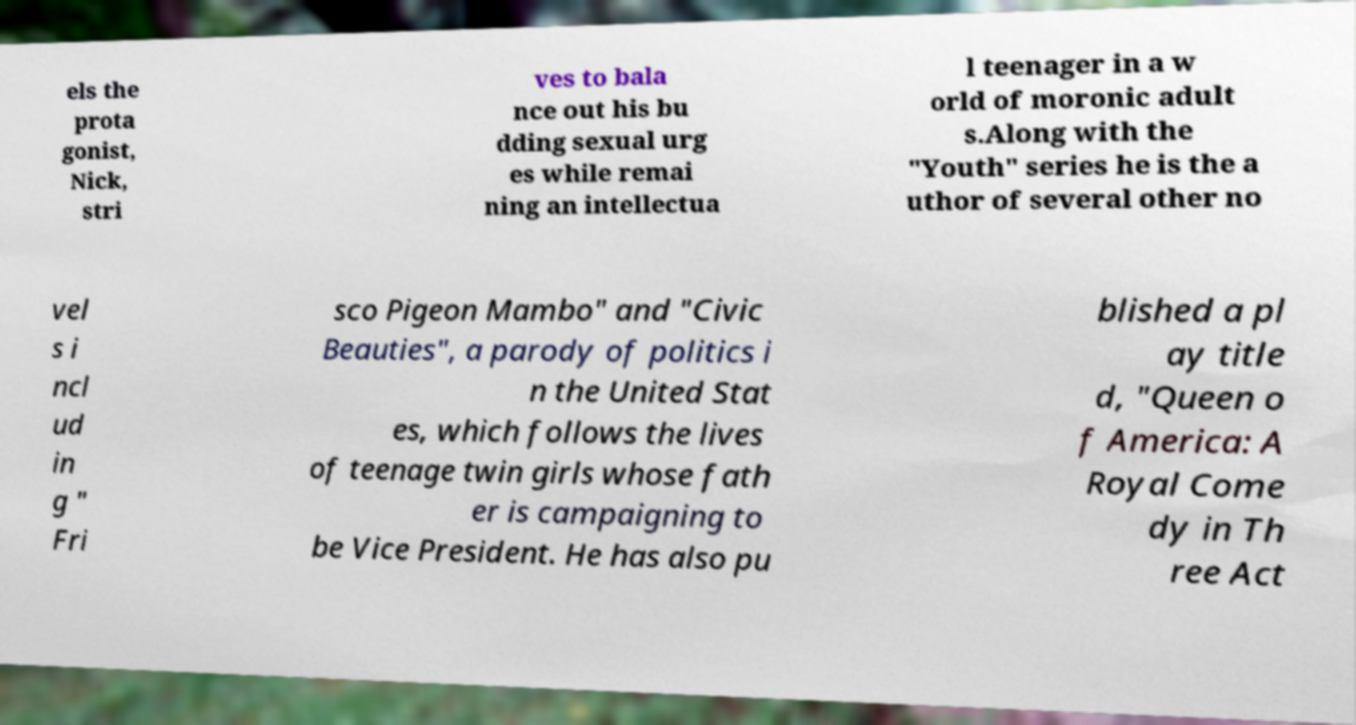What messages or text are displayed in this image? I need them in a readable, typed format. els the prota gonist, Nick, stri ves to bala nce out his bu dding sexual urg es while remai ning an intellectua l teenager in a w orld of moronic adult s.Along with the "Youth" series he is the a uthor of several other no vel s i ncl ud in g " Fri sco Pigeon Mambo" and "Civic Beauties", a parody of politics i n the United Stat es, which follows the lives of teenage twin girls whose fath er is campaigning to be Vice President. He has also pu blished a pl ay title d, "Queen o f America: A Royal Come dy in Th ree Act 